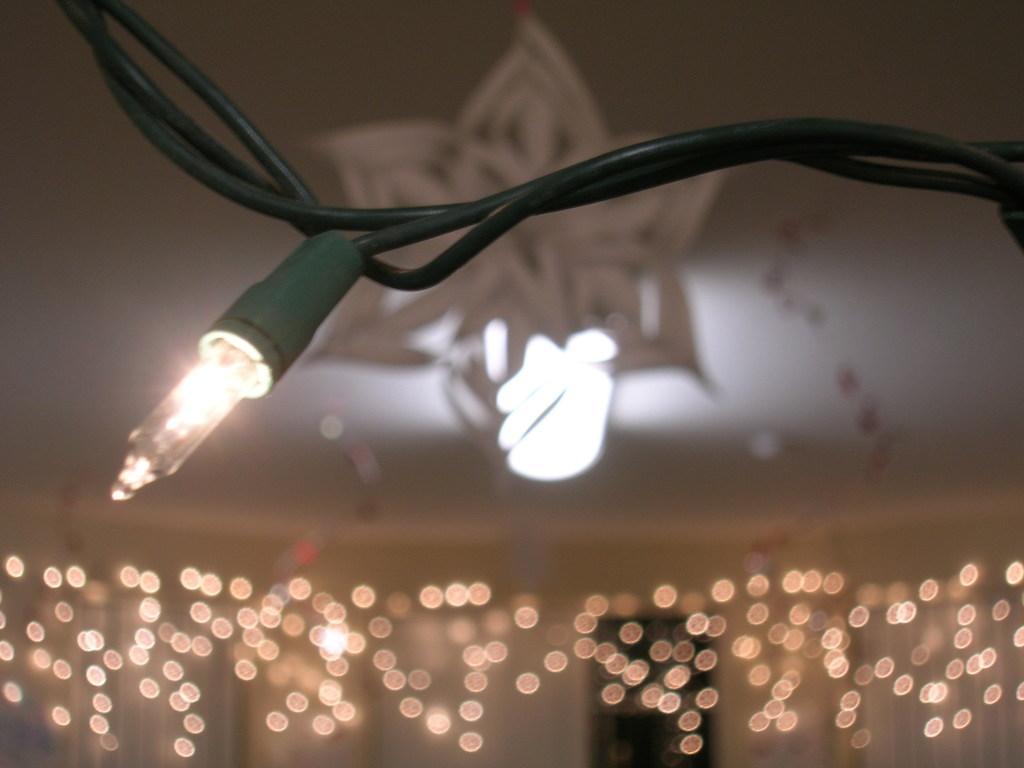Describe this image in one or two sentences. In this image we can see a light attached with some wires and there are some lights with blurry background. 